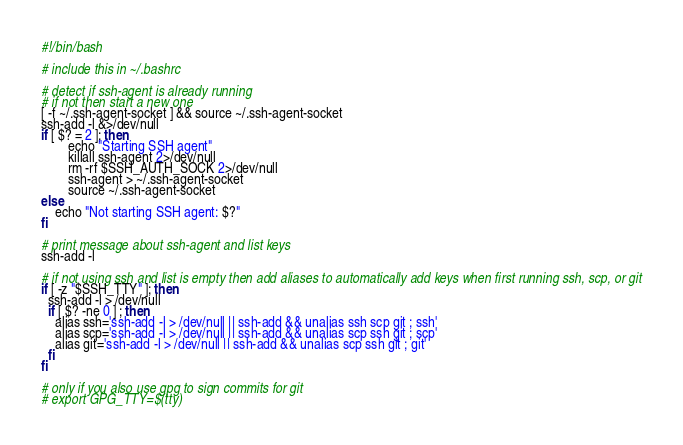<code> <loc_0><loc_0><loc_500><loc_500><_Bash_>#!/bin/bash

# include this in ~/.bashrc

# detect if ssh-agent is already running
# if not then start a new one
[ -f ~/.ssh-agent-socket ] && source ~/.ssh-agent-socket
ssh-add -l &>/dev/null
if [ $? = 2 ]; then
        echo "Starting SSH agent"
        killall ssh-agent 2>/dev/null
        rm -rf $SSH_AUTH_SOCK 2>/dev/null
        ssh-agent > ~/.ssh-agent-socket
        source ~/.ssh-agent-socket
else
	echo "Not starting SSH agent: $?"
fi

# print message about ssh-agent and list keys
ssh-add -l

# if not using ssh and list is empty then add aliases to automatically add keys when first running ssh, scp, or git
if [ -z "$SSH_TTY" ]; then
  ssh-add -l > /dev/null
  if [ $? -ne 0 ] ; then
    alias ssh='ssh-add -l > /dev/null || ssh-add && unalias ssh scp git ; ssh'
    alias scp='ssh-add -l > /dev/null || ssh-add && unalias scp ssh git ; scp'
    alias git='ssh-add -l > /dev/null || ssh-add && unalias scp ssh git ; git'
  fi
fi

# only if you also use gpg to sign commits for git
# export GPG_TTY=$(tty)
</code> 